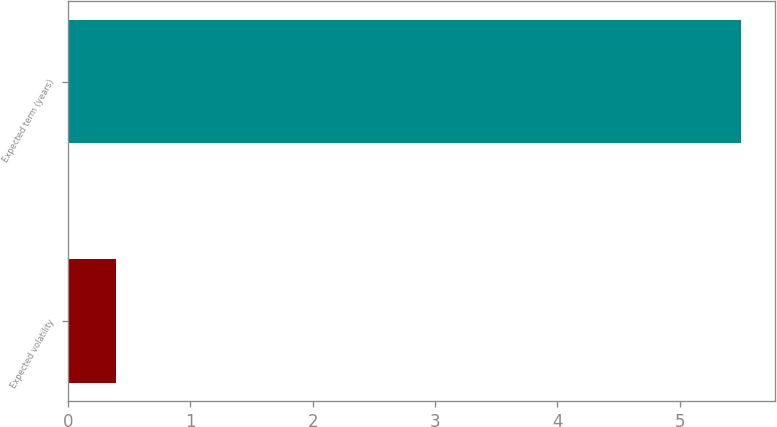Convert chart to OTSL. <chart><loc_0><loc_0><loc_500><loc_500><bar_chart><fcel>Expected volatility<fcel>Expected term (years)<nl><fcel>0.39<fcel>5.5<nl></chart> 